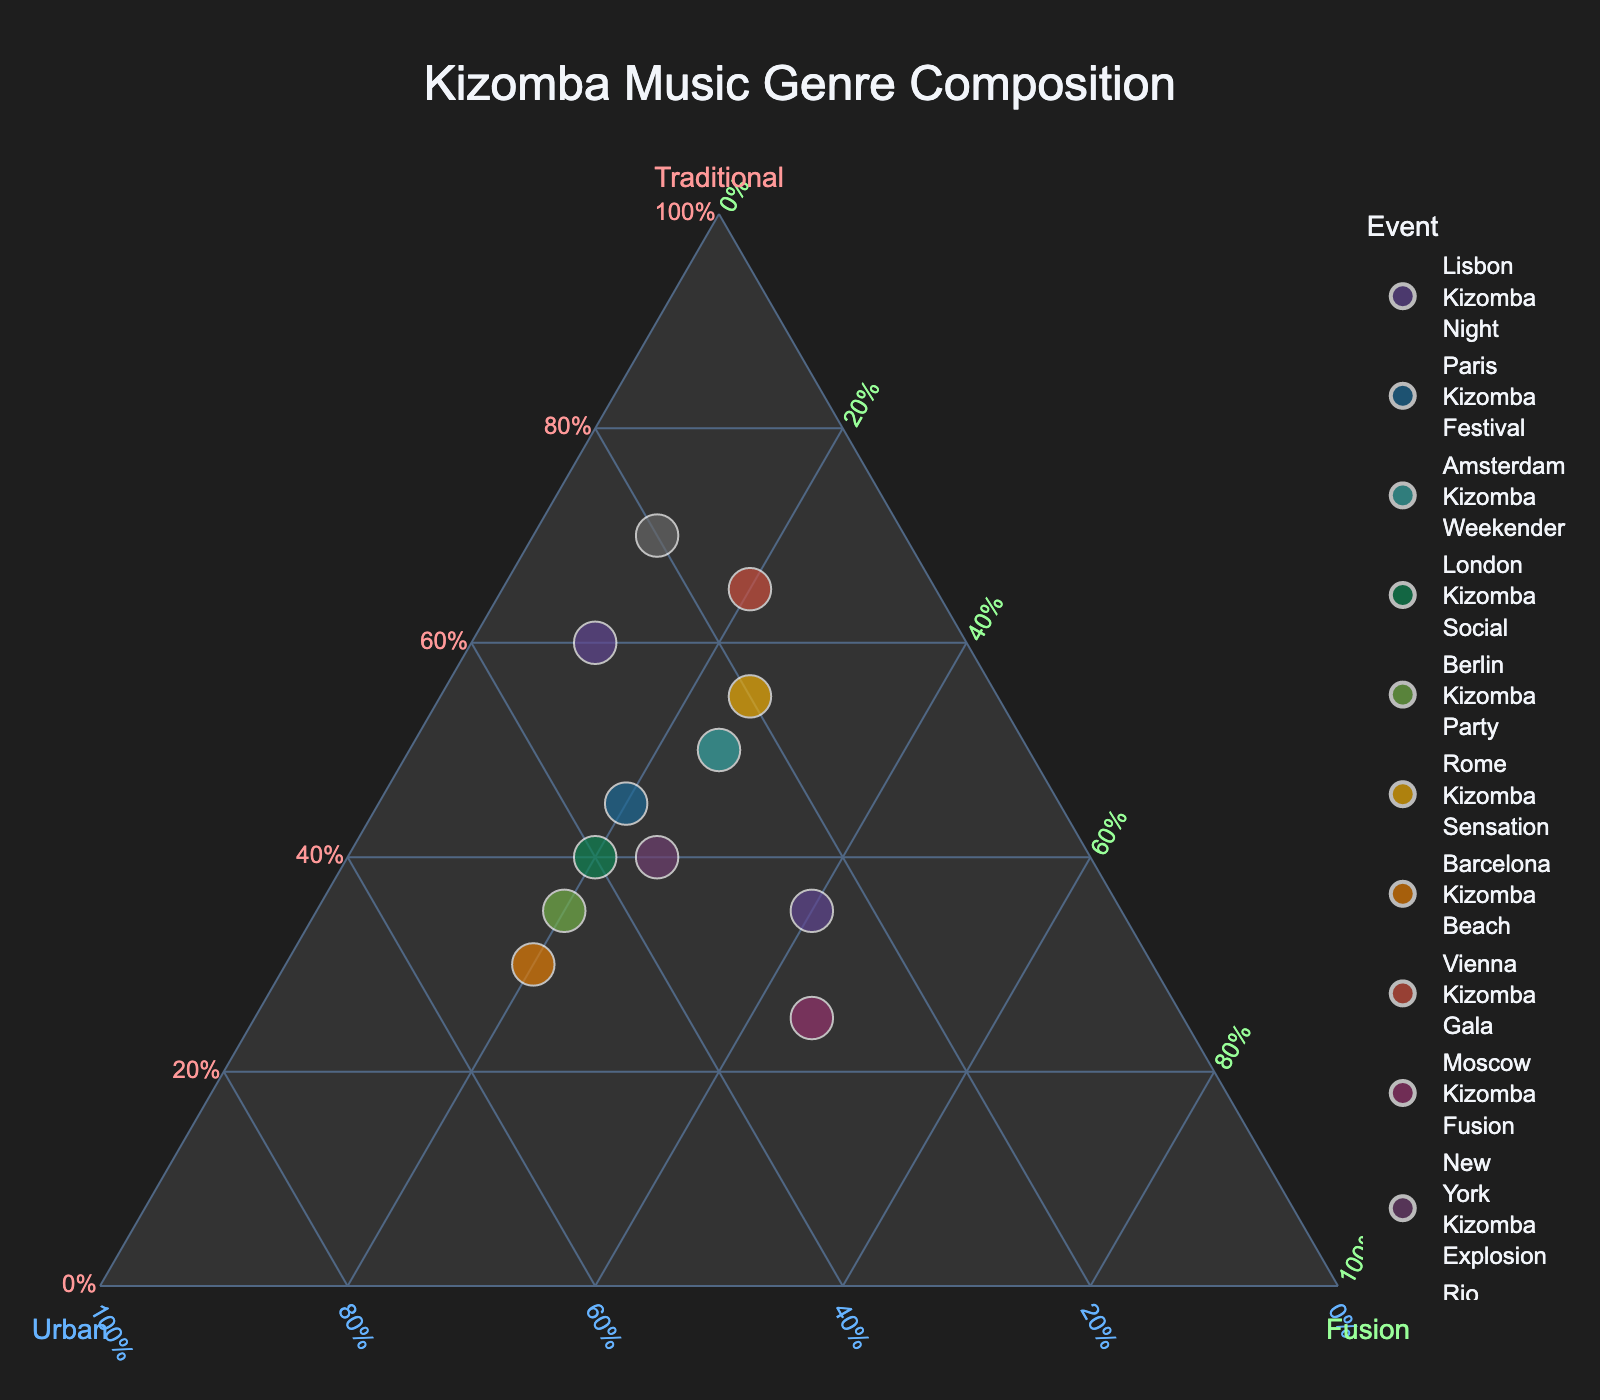How many events are represented in the plot? Count the number of data points or markers in the figure. Each point corresponds to an event.
Answer: 12 Which event has the highest percentage of traditional tracks? Look for the point furthest along the "Traditional" axis, indicating the largest proportion of traditional tracks.
Answer: Rio Kizomba Carnival What is the average percentage of urban tracks across all the events? To find the average, sum up the percentages of urban tracks for each event (30 + 35 + 25 + 40 + 45 + 20 + 50 + 15 + 30 + 35 + 20 + 25) = 370%, then divide by the number of events (12).
Answer: 30.8% Which two events have the same percentage of fusion tracks? Compare the percentages of fusion tracks for each event and identify the ones that match (10, 20, 25, 20, 20, 25, 20, 20, 45, 25, 10, 40). Identify events with the same value.
Answer: Paris Kizomba Festival and Berlin Kizomba Party (20% each), Amsterdam Kizomba Weekender and New York Kizomba Explosion (25% each) Which event has the closest composition to an equal split among traditional, urban, and fusion tracks? Look for the point closest to the center of the plot, indicating a roughly equal mixture of traditional, urban, and fusion tracks.
Answer: Amsterdam Kizomba Weekender What's the percentage difference in traditional tracks between Lisbon Kizomba Night and Vienna Kizomba Gala? Subtract the smaller percentage from the larger (65% - 60%).
Answer: 5% Which event has the smallest percentage of urban tracks? Find the point along the "Urban" axis with the smallest value.
Answer: Vienna Kizomba Gala Are there any events where fusion tracks make up half or more of the total content? Scan for points where the "Fusion" axis value is 50% or more.
Answer: None How does the composition of traditional and urban tracks at London Kizomba Social compare to Barcelona Kizomba Beach? Identify the percentages for both events (London: 40% traditional, 40% urban; Barcelona: 30% traditional, 50% urban) and compare them.
Answer: London Kizomba Social has a higher percentage of traditional and a lower percentage of urban tracks than Barcelona Kizomba Beach Which event has the most balanced distribution among the three genres? Find the point closest to being equidistant from all three axes, indicating a balanced mix of traditional, urban, and fusion tracks.
Answer: Tokyo Kizomba Nights 